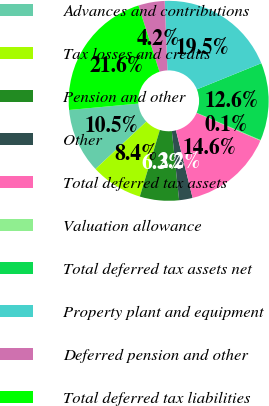<chart> <loc_0><loc_0><loc_500><loc_500><pie_chart><fcel>Advances and contributions<fcel>Tax losses and credits<fcel>Pension and other<fcel>Other<fcel>Total deferred tax assets<fcel>Valuation allowance<fcel>Total deferred tax assets net<fcel>Property plant and equipment<fcel>Deferred pension and other<fcel>Total deferred tax liabilities<nl><fcel>10.48%<fcel>8.4%<fcel>6.33%<fcel>2.18%<fcel>14.63%<fcel>0.1%<fcel>12.55%<fcel>19.5%<fcel>4.25%<fcel>21.58%<nl></chart> 